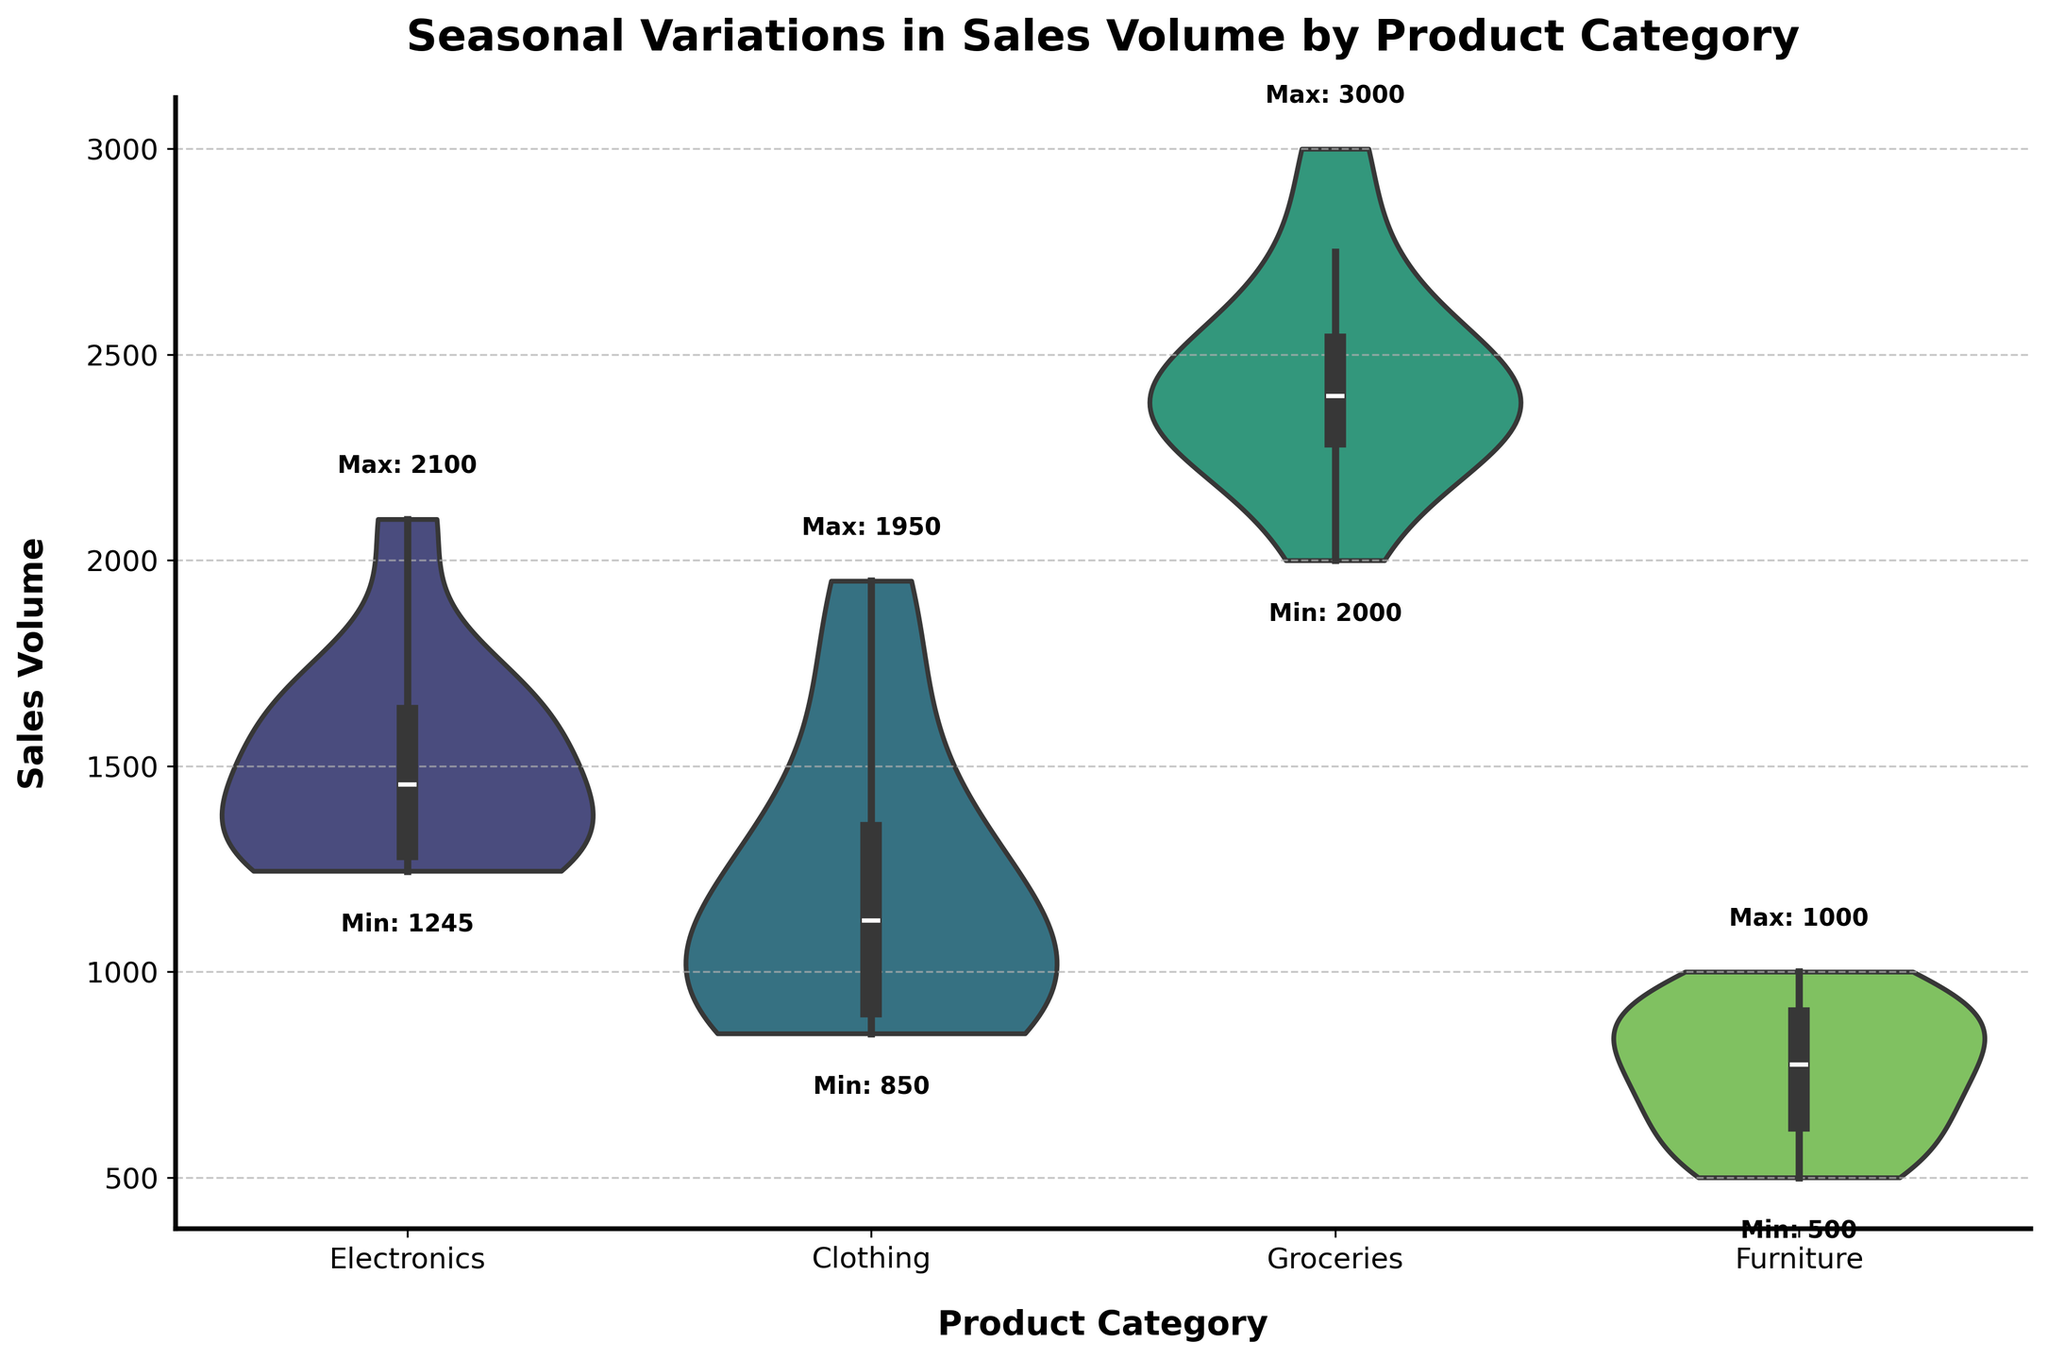What's the title of the figure? The title is displayed at the top of the figure and usually provides a summary of what the figure is about. Here, it states 'Seasonal Variations in Sales Volume by Product Category'.
Answer: Seasonal Variations in Sales Volume by Product Category Which product category has the highest maximum sales volume? By observing the text annotations above each violin, the one with the highest value corresponds to the 'Groceries' category. The label 'Max: 3000' appears at the top.
Answer: Groceries What are the minimum sales volumes for Electronics and Clothing? The violin plots have text annotations at the bottom indicating the minimum sales volumes. For 'Electronics', the annotation shows 'Min: 1245', and for 'Clothing', it shows 'Min: 850'.
Answer: 1245 for Electronics, 850 for Clothing Which category shows the smallest variation in sales volumes throughout the year? By examining the width and spread of each violin plot, 'Furniture' appears to have the smallest variation since it is the most narrow and vertically limited.
Answer: Furniture How does the median sales volume of Electronics compare to that of Clothing? The internal box plot in each violin indicates the median. Comparing the positions visually, the Electronics median seems higher than that of Clothing.
Answer: Electronics has a higher median What is the range of sales volumes for Groceries? To find the range, we subtract the minimum sales volume from the maximum. For Groceries, the range is 3000 (Max) - 2000 (Min) = 1000.
Answer: 1000 Which category experiences the greatest increase in sales towards the end of the year? Looking at the shape and distribution of the violins, 'Electronics' and 'Clothing' both show increased densities towards the top, but Groceries exhibit the largest end-year bump with the highest December value.
Answer: Groceries What product category has the highest sales volume in December? The figure has annotations indicating sales volumes; the highest for December is shown for the Groceries category with 3000.
Answer: Groceries Are there any months where Clothing and Furniture have similar sales volumes? By analyzing the sales distributions for Clothing and Furniture, both categories have narrower violins, indicating smaller ranges, and show overlaps around mid-year (June-August).
Answer: Yes, around mid-year What's the overall trend in sales volumes for all categories towards the end of the year? All categories' violins exhibit a wider top part towards the end of the year, indicating an overall trend in increased sales volumes, particularly in November and December.
Answer: Increase 